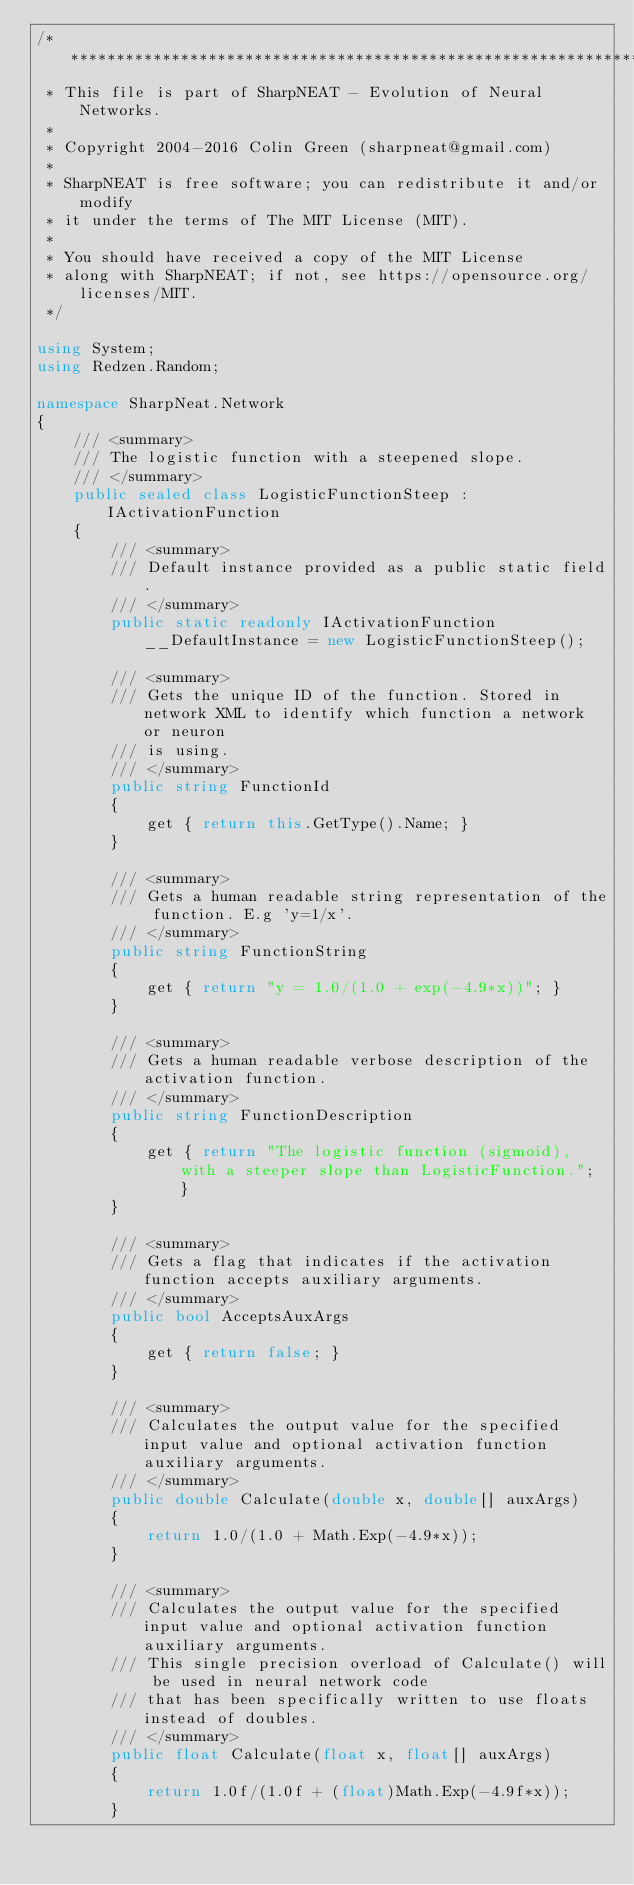<code> <loc_0><loc_0><loc_500><loc_500><_C#_>/* ***************************************************************************
 * This file is part of SharpNEAT - Evolution of Neural Networks.
 * 
 * Copyright 2004-2016 Colin Green (sharpneat@gmail.com)
 *
 * SharpNEAT is free software; you can redistribute it and/or modify
 * it under the terms of The MIT License (MIT).
 *
 * You should have received a copy of the MIT License
 * along with SharpNEAT; if not, see https://opensource.org/licenses/MIT.
 */

using System;
using Redzen.Random;

namespace SharpNeat.Network
{
    /// <summary>
    /// The logistic function with a steepened slope.
    /// </summary>
    public sealed class LogisticFunctionSteep : IActivationFunction
    {
        /// <summary>
        /// Default instance provided as a public static field.
        /// </summary>
        public static readonly IActivationFunction __DefaultInstance = new LogisticFunctionSteep();

        /// <summary>
        /// Gets the unique ID of the function. Stored in network XML to identify which function a network or neuron 
        /// is using.
        /// </summary>
        public string FunctionId
        {
            get { return this.GetType().Name; }
        }

        /// <summary>
        /// Gets a human readable string representation of the function. E.g 'y=1/x'.
        /// </summary>
        public string FunctionString
        {
            get { return "y = 1.0/(1.0 + exp(-4.9*x))"; }
        }

        /// <summary>
        /// Gets a human readable verbose description of the activation function.
        /// </summary>
        public string FunctionDescription
        {
            get { return "The logistic function (sigmoid), with a steeper slope than LogisticFunction."; }
        }

        /// <summary>
        /// Gets a flag that indicates if the activation function accepts auxiliary arguments.
        /// </summary>
        public bool AcceptsAuxArgs 
        { 
            get { return false; }
        } 

        /// <summary>
        /// Calculates the output value for the specified input value and optional activation function auxiliary arguments.
        /// </summary>
        public double Calculate(double x, double[] auxArgs)
        {
            return 1.0/(1.0 + Math.Exp(-4.9*x));
        }

        /// <summary>
        /// Calculates the output value for the specified input value and optional activation function auxiliary arguments.
        /// This single precision overload of Calculate() will be used in neural network code 
        /// that has been specifically written to use floats instead of doubles.
        /// </summary>
        public float Calculate(float x, float[] auxArgs)
        {
            return 1.0f/(1.0f + (float)Math.Exp(-4.9f*x));
        }
</code> 